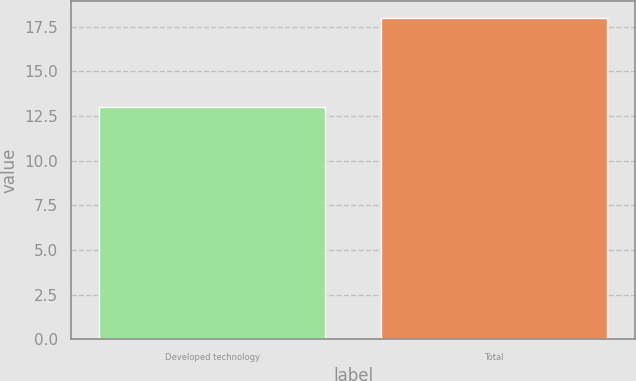Convert chart to OTSL. <chart><loc_0><loc_0><loc_500><loc_500><bar_chart><fcel>Developed technology<fcel>Total<nl><fcel>13<fcel>18<nl></chart> 